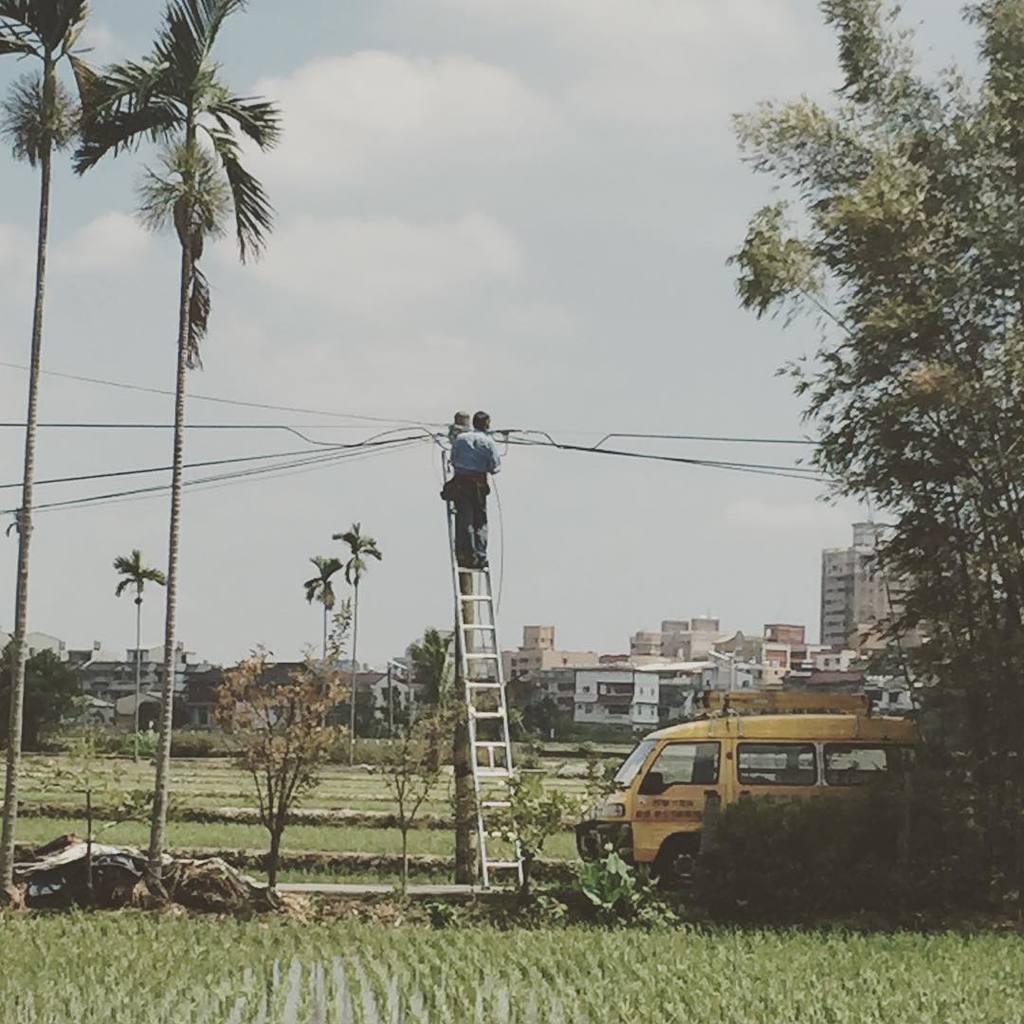Please provide a concise description of this image. This is completely an outdoor picture. At the top of the picture we can see a sky and it seems like a cloudy day. On the background we can see buildings. These are the the trees. This is a field. Here we can see one man standing on the ladder and working. At the right side of the picture we can see a tree. Near to it there is a vehicle in yellow colour. 